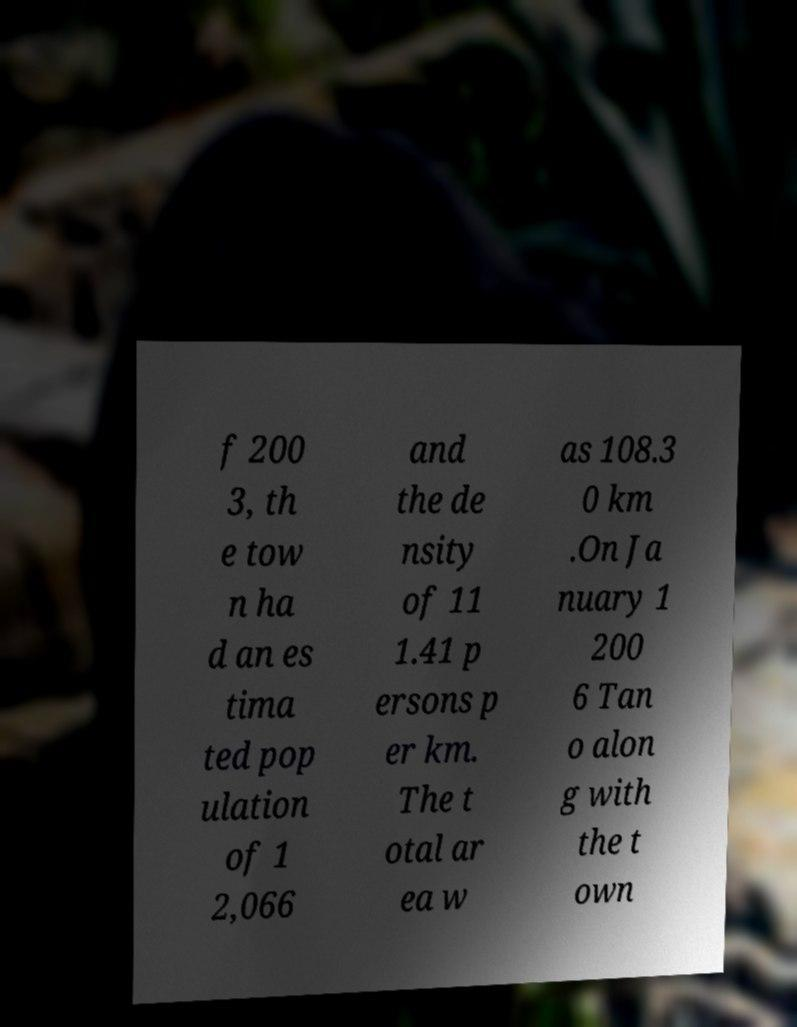Could you extract and type out the text from this image? f 200 3, th e tow n ha d an es tima ted pop ulation of 1 2,066 and the de nsity of 11 1.41 p ersons p er km. The t otal ar ea w as 108.3 0 km .On Ja nuary 1 200 6 Tan o alon g with the t own 